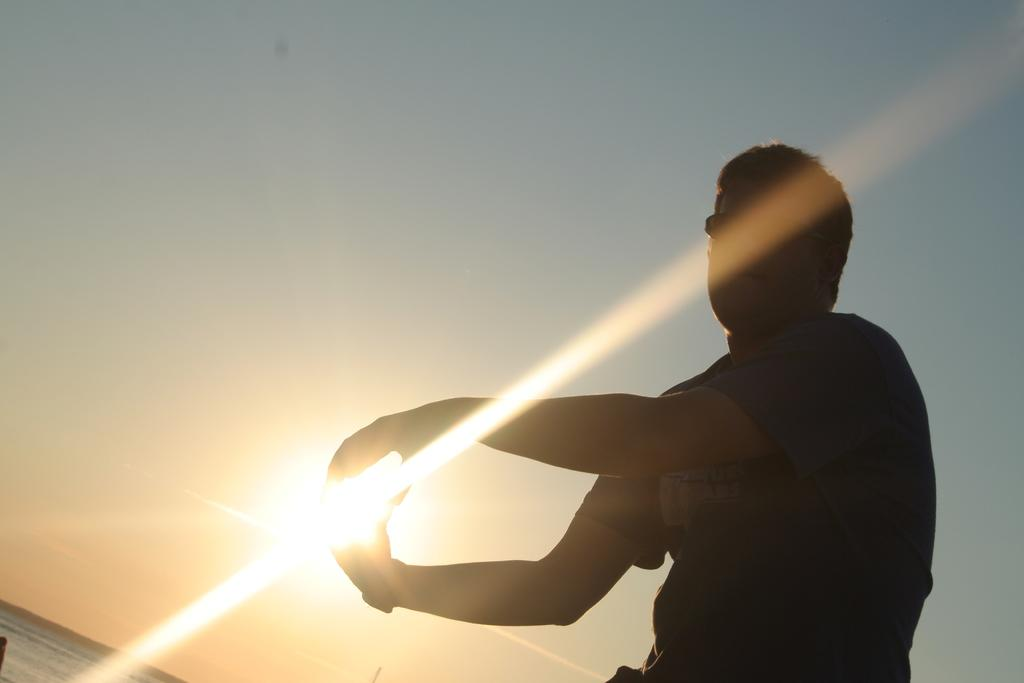What is the main subject of the image? There is a person standing in the image. What can be seen in the background of the image? The sunlight and sky are visible in the background of the image. Is there any water visible in the image? Yes, there is water visible in the image. What type of support can be seen holding up the guitar in the image? There is no guitar present in the image, so there is no support for it. 